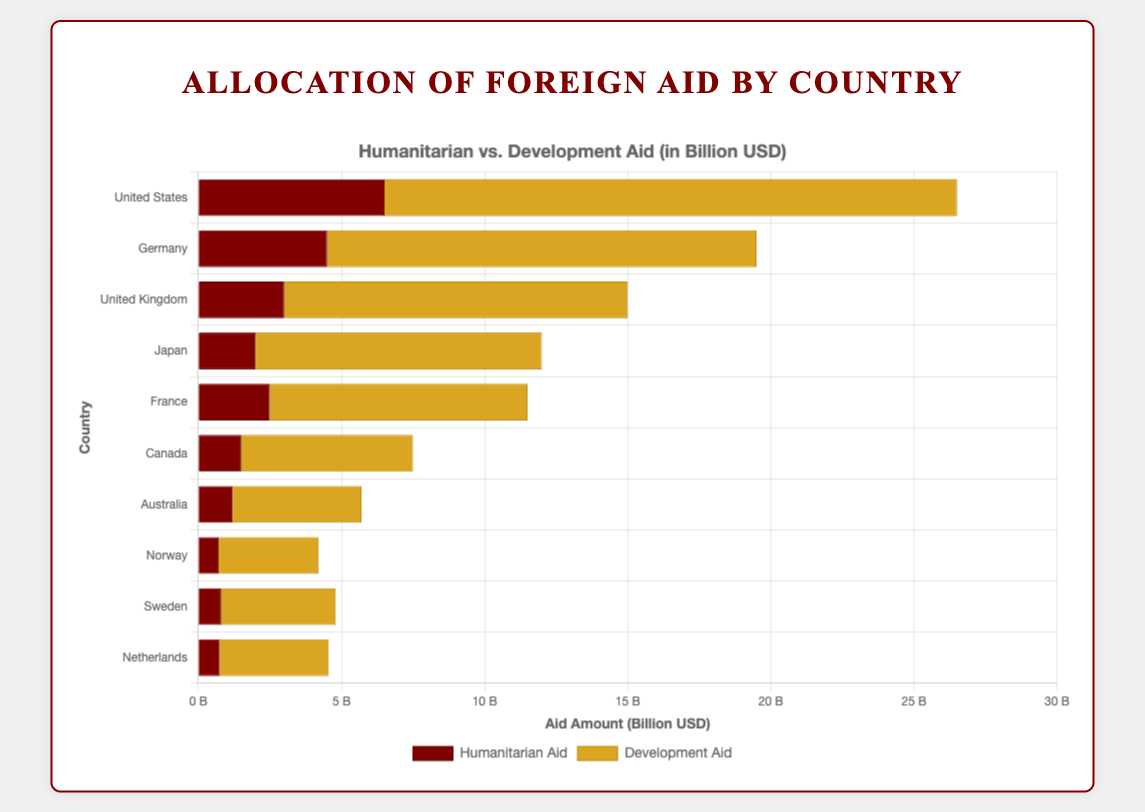Which country allocates the highest total amount of foreign aid? To find the country with the highest total allocation, we add the Humanitarian Aid and Development Aid for each country. The United States has the highest totals: $6.5B (Humanitarian) + $20B (Development) = $26.5B.
Answer: United States Which country provides more Humanitarian Aid: Germany or the United Kingdom? Compare the Humanitarian Aid amounts: Germany provides $4.5B and the United Kingdom provides $3B.
Answer: Germany What is the total amount of Development Aid provided by Japan and France combined? Sum the Development Aid for both countries: Japan with $10B and France with $9B results in $10B + $9B = $19B.
Answer: $19B How much more Development Aid does the United States provide compared to Canada? Subtract Canada's Development Aid from that of the United States: $20B (United States) - $6B (Canada) = $14B.
Answer: $14B Which countries allocate more to Humanitarian Aid than Development Aid? Check each country to see if Humanitarian Aid is greater: None of the countries allocate more to Humanitarian Aid than Development Aid.
Answer: None What’s the total amount of aid provided by Sweden? Sum Sweden's Humanitarian Aid and Development Aid: $0.8B (Humanitarian) + $4B (Development) = $4.8B.
Answer: $4.8B What is the average Development Aid provided by the United States, Germany, and the United Kingdom? Calculate the average: ($20B + $15B + $12B) / 3 = $47B / 3 ≈ $15.67B.
Answer: $15.67B Rank the top three countries in terms of total foreign aid. Total aid is the sum of Humanitarian and Development Aid:
1. United States: $26.5B
2. Germany: $19.5B
3. United Kingdom: $15B.
Answer: 1. United States, 2. Germany, 3. United Kingdom Compare the proportions of Humanitarian and Development Aid in Australia. Is one significantly higher? Compare the Humanitarian Aid ($1.2B) and Development Aid ($4.5B): Development Aid is significantly higher.
Answer: Development Aid significantly higher Which country allocates the least Humanitarian Aid, and how much is it? Norway allocates the least amount of Humanitarian Aid, which is $0.7B.
Answer: Norway, $0.7B 